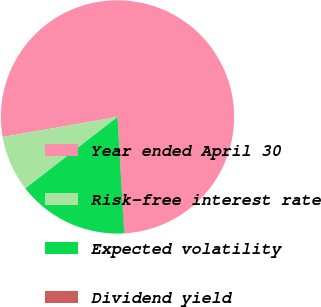Convert chart. <chart><loc_0><loc_0><loc_500><loc_500><pie_chart><fcel>Year ended April 30<fcel>Risk-free interest rate<fcel>Expected volatility<fcel>Dividend yield<nl><fcel>76.78%<fcel>7.74%<fcel>15.41%<fcel>0.07%<nl></chart> 